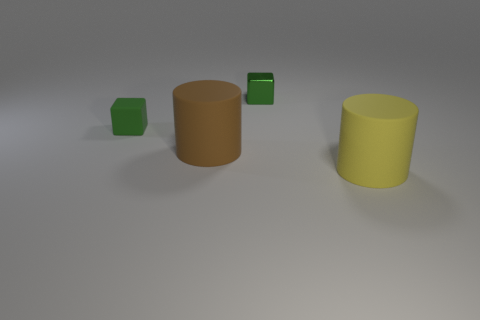What is the shape of the other tiny object that is the same color as the small metal object?
Give a very brief answer. Cube. What is the size of the other block that is the same color as the rubber block?
Provide a short and direct response. Small. There is a matte cylinder that is the same size as the brown rubber object; what color is it?
Keep it short and to the point. Yellow. Is the number of yellow things that are behind the big yellow cylinder less than the number of objects on the left side of the rubber cube?
Your answer should be compact. No. Do the matte thing on the left side of the brown cylinder and the large brown rubber cylinder have the same size?
Offer a terse response. No. The object on the right side of the metallic cube has what shape?
Ensure brevity in your answer.  Cylinder. Is the number of small blocks greater than the number of big yellow cylinders?
Ensure brevity in your answer.  Yes. Do the tiny block that is on the right side of the green rubber cube and the small matte block have the same color?
Your response must be concise. Yes. How many things are either matte cylinders on the right side of the brown rubber thing or small green objects that are to the left of the small green metal object?
Ensure brevity in your answer.  2. What number of objects are both behind the large brown thing and in front of the green shiny cube?
Make the answer very short. 1. 